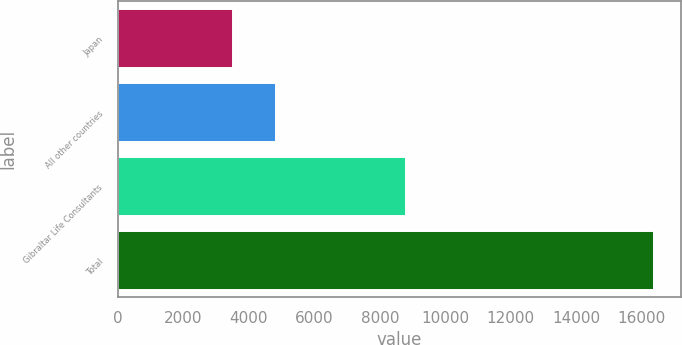Convert chart. <chart><loc_0><loc_0><loc_500><loc_500><bar_chart><fcel>Japan<fcel>All other countries<fcel>Gibraltar Life Consultants<fcel>Total<nl><fcel>3528<fcel>4814.9<fcel>8805<fcel>16397<nl></chart> 